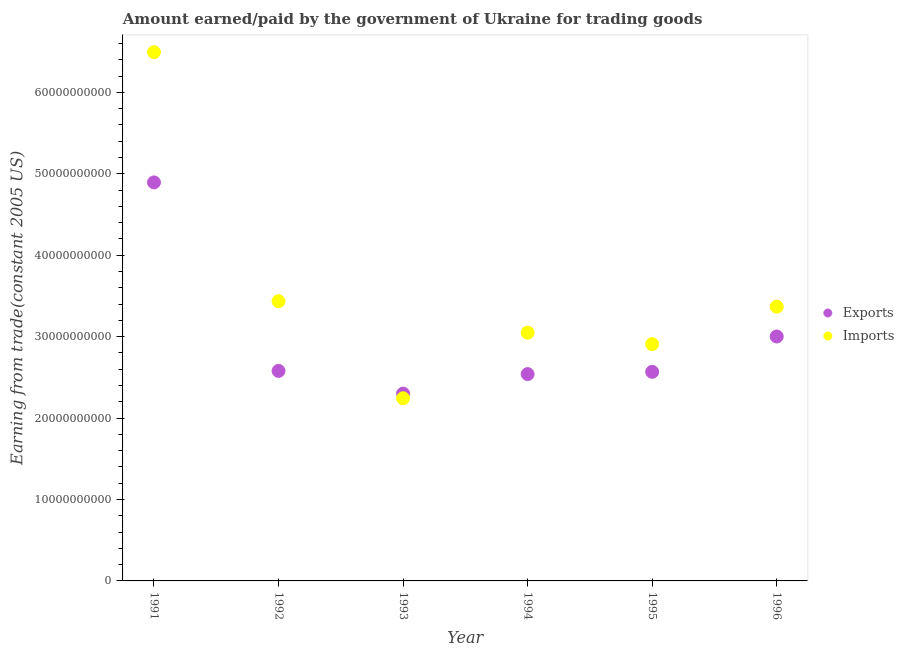Is the number of dotlines equal to the number of legend labels?
Offer a terse response. Yes. What is the amount earned from exports in 1993?
Keep it short and to the point. 2.30e+1. Across all years, what is the maximum amount earned from exports?
Give a very brief answer. 4.89e+1. Across all years, what is the minimum amount paid for imports?
Make the answer very short. 2.24e+1. In which year was the amount earned from exports minimum?
Your answer should be very brief. 1993. What is the total amount earned from exports in the graph?
Offer a very short reply. 1.79e+11. What is the difference between the amount paid for imports in 1991 and that in 1994?
Your answer should be compact. 3.44e+1. What is the difference between the amount paid for imports in 1991 and the amount earned from exports in 1995?
Offer a very short reply. 3.93e+1. What is the average amount paid for imports per year?
Your answer should be compact. 3.58e+1. In the year 1991, what is the difference between the amount earned from exports and amount paid for imports?
Offer a very short reply. -1.60e+1. What is the ratio of the amount paid for imports in 1993 to that in 1995?
Your answer should be very brief. 0.77. Is the amount paid for imports in 1993 less than that in 1996?
Your answer should be very brief. Yes. What is the difference between the highest and the second highest amount earned from exports?
Your response must be concise. 1.89e+1. What is the difference between the highest and the lowest amount paid for imports?
Keep it short and to the point. 4.25e+1. Does the amount paid for imports monotonically increase over the years?
Make the answer very short. No. Is the amount earned from exports strictly less than the amount paid for imports over the years?
Keep it short and to the point. No. How many dotlines are there?
Offer a very short reply. 2. How many years are there in the graph?
Offer a terse response. 6. How many legend labels are there?
Offer a terse response. 2. What is the title of the graph?
Your response must be concise. Amount earned/paid by the government of Ukraine for trading goods. What is the label or title of the Y-axis?
Offer a very short reply. Earning from trade(constant 2005 US). What is the Earning from trade(constant 2005 US) in Exports in 1991?
Keep it short and to the point. 4.89e+1. What is the Earning from trade(constant 2005 US) in Imports in 1991?
Your response must be concise. 6.49e+1. What is the Earning from trade(constant 2005 US) in Exports in 1992?
Your answer should be very brief. 2.58e+1. What is the Earning from trade(constant 2005 US) in Imports in 1992?
Offer a very short reply. 3.43e+1. What is the Earning from trade(constant 2005 US) of Exports in 1993?
Provide a short and direct response. 2.30e+1. What is the Earning from trade(constant 2005 US) of Imports in 1993?
Your answer should be compact. 2.24e+1. What is the Earning from trade(constant 2005 US) in Exports in 1994?
Make the answer very short. 2.54e+1. What is the Earning from trade(constant 2005 US) of Imports in 1994?
Keep it short and to the point. 3.05e+1. What is the Earning from trade(constant 2005 US) in Exports in 1995?
Keep it short and to the point. 2.57e+1. What is the Earning from trade(constant 2005 US) in Imports in 1995?
Offer a very short reply. 2.91e+1. What is the Earning from trade(constant 2005 US) in Exports in 1996?
Your response must be concise. 3.00e+1. What is the Earning from trade(constant 2005 US) in Imports in 1996?
Keep it short and to the point. 3.37e+1. Across all years, what is the maximum Earning from trade(constant 2005 US) in Exports?
Offer a terse response. 4.89e+1. Across all years, what is the maximum Earning from trade(constant 2005 US) in Imports?
Your answer should be compact. 6.49e+1. Across all years, what is the minimum Earning from trade(constant 2005 US) in Exports?
Provide a short and direct response. 2.30e+1. Across all years, what is the minimum Earning from trade(constant 2005 US) of Imports?
Give a very brief answer. 2.24e+1. What is the total Earning from trade(constant 2005 US) of Exports in the graph?
Give a very brief answer. 1.79e+11. What is the total Earning from trade(constant 2005 US) of Imports in the graph?
Provide a succinct answer. 2.15e+11. What is the difference between the Earning from trade(constant 2005 US) in Exports in 1991 and that in 1992?
Ensure brevity in your answer.  2.31e+1. What is the difference between the Earning from trade(constant 2005 US) in Imports in 1991 and that in 1992?
Make the answer very short. 3.06e+1. What is the difference between the Earning from trade(constant 2005 US) of Exports in 1991 and that in 1993?
Make the answer very short. 2.59e+1. What is the difference between the Earning from trade(constant 2005 US) in Imports in 1991 and that in 1993?
Give a very brief answer. 4.25e+1. What is the difference between the Earning from trade(constant 2005 US) in Exports in 1991 and that in 1994?
Make the answer very short. 2.35e+1. What is the difference between the Earning from trade(constant 2005 US) in Imports in 1991 and that in 1994?
Offer a very short reply. 3.44e+1. What is the difference between the Earning from trade(constant 2005 US) in Exports in 1991 and that in 1995?
Offer a terse response. 2.33e+1. What is the difference between the Earning from trade(constant 2005 US) in Imports in 1991 and that in 1995?
Offer a terse response. 3.58e+1. What is the difference between the Earning from trade(constant 2005 US) in Exports in 1991 and that in 1996?
Make the answer very short. 1.89e+1. What is the difference between the Earning from trade(constant 2005 US) of Imports in 1991 and that in 1996?
Your answer should be compact. 3.13e+1. What is the difference between the Earning from trade(constant 2005 US) of Exports in 1992 and that in 1993?
Ensure brevity in your answer.  2.79e+09. What is the difference between the Earning from trade(constant 2005 US) in Imports in 1992 and that in 1993?
Your answer should be compact. 1.19e+1. What is the difference between the Earning from trade(constant 2005 US) of Exports in 1992 and that in 1994?
Keep it short and to the point. 3.93e+08. What is the difference between the Earning from trade(constant 2005 US) in Imports in 1992 and that in 1994?
Keep it short and to the point. 3.87e+09. What is the difference between the Earning from trade(constant 2005 US) in Exports in 1992 and that in 1995?
Give a very brief answer. 1.13e+08. What is the difference between the Earning from trade(constant 2005 US) of Imports in 1992 and that in 1995?
Provide a succinct answer. 5.27e+09. What is the difference between the Earning from trade(constant 2005 US) in Exports in 1992 and that in 1996?
Ensure brevity in your answer.  -4.23e+09. What is the difference between the Earning from trade(constant 2005 US) in Imports in 1992 and that in 1996?
Provide a succinct answer. 6.74e+08. What is the difference between the Earning from trade(constant 2005 US) in Exports in 1993 and that in 1994?
Keep it short and to the point. -2.39e+09. What is the difference between the Earning from trade(constant 2005 US) of Imports in 1993 and that in 1994?
Offer a very short reply. -8.05e+09. What is the difference between the Earning from trade(constant 2005 US) of Exports in 1993 and that in 1995?
Offer a very short reply. -2.67e+09. What is the difference between the Earning from trade(constant 2005 US) in Imports in 1993 and that in 1995?
Offer a very short reply. -6.65e+09. What is the difference between the Earning from trade(constant 2005 US) in Exports in 1993 and that in 1996?
Ensure brevity in your answer.  -7.01e+09. What is the difference between the Earning from trade(constant 2005 US) of Imports in 1993 and that in 1996?
Provide a succinct answer. -1.12e+1. What is the difference between the Earning from trade(constant 2005 US) of Exports in 1994 and that in 1995?
Keep it short and to the point. -2.79e+08. What is the difference between the Earning from trade(constant 2005 US) in Imports in 1994 and that in 1995?
Keep it short and to the point. 1.40e+09. What is the difference between the Earning from trade(constant 2005 US) of Exports in 1994 and that in 1996?
Make the answer very short. -4.62e+09. What is the difference between the Earning from trade(constant 2005 US) in Imports in 1994 and that in 1996?
Provide a short and direct response. -3.19e+09. What is the difference between the Earning from trade(constant 2005 US) in Exports in 1995 and that in 1996?
Provide a short and direct response. -4.34e+09. What is the difference between the Earning from trade(constant 2005 US) in Imports in 1995 and that in 1996?
Your answer should be compact. -4.59e+09. What is the difference between the Earning from trade(constant 2005 US) of Exports in 1991 and the Earning from trade(constant 2005 US) of Imports in 1992?
Offer a very short reply. 1.46e+1. What is the difference between the Earning from trade(constant 2005 US) of Exports in 1991 and the Earning from trade(constant 2005 US) of Imports in 1993?
Your answer should be very brief. 2.65e+1. What is the difference between the Earning from trade(constant 2005 US) in Exports in 1991 and the Earning from trade(constant 2005 US) in Imports in 1994?
Offer a very short reply. 1.85e+1. What is the difference between the Earning from trade(constant 2005 US) of Exports in 1991 and the Earning from trade(constant 2005 US) of Imports in 1995?
Provide a short and direct response. 1.99e+1. What is the difference between the Earning from trade(constant 2005 US) in Exports in 1991 and the Earning from trade(constant 2005 US) in Imports in 1996?
Your answer should be very brief. 1.53e+1. What is the difference between the Earning from trade(constant 2005 US) in Exports in 1992 and the Earning from trade(constant 2005 US) in Imports in 1993?
Ensure brevity in your answer.  3.36e+09. What is the difference between the Earning from trade(constant 2005 US) of Exports in 1992 and the Earning from trade(constant 2005 US) of Imports in 1994?
Offer a terse response. -4.69e+09. What is the difference between the Earning from trade(constant 2005 US) in Exports in 1992 and the Earning from trade(constant 2005 US) in Imports in 1995?
Provide a succinct answer. -3.29e+09. What is the difference between the Earning from trade(constant 2005 US) in Exports in 1992 and the Earning from trade(constant 2005 US) in Imports in 1996?
Your response must be concise. -7.88e+09. What is the difference between the Earning from trade(constant 2005 US) in Exports in 1993 and the Earning from trade(constant 2005 US) in Imports in 1994?
Your answer should be very brief. -7.48e+09. What is the difference between the Earning from trade(constant 2005 US) in Exports in 1993 and the Earning from trade(constant 2005 US) in Imports in 1995?
Offer a terse response. -6.07e+09. What is the difference between the Earning from trade(constant 2005 US) in Exports in 1993 and the Earning from trade(constant 2005 US) in Imports in 1996?
Your answer should be compact. -1.07e+1. What is the difference between the Earning from trade(constant 2005 US) in Exports in 1994 and the Earning from trade(constant 2005 US) in Imports in 1995?
Ensure brevity in your answer.  -3.68e+09. What is the difference between the Earning from trade(constant 2005 US) of Exports in 1994 and the Earning from trade(constant 2005 US) of Imports in 1996?
Provide a succinct answer. -8.28e+09. What is the difference between the Earning from trade(constant 2005 US) in Exports in 1995 and the Earning from trade(constant 2005 US) in Imports in 1996?
Ensure brevity in your answer.  -8.00e+09. What is the average Earning from trade(constant 2005 US) in Exports per year?
Offer a terse response. 2.98e+1. What is the average Earning from trade(constant 2005 US) in Imports per year?
Your response must be concise. 3.58e+1. In the year 1991, what is the difference between the Earning from trade(constant 2005 US) of Exports and Earning from trade(constant 2005 US) of Imports?
Offer a very short reply. -1.60e+1. In the year 1992, what is the difference between the Earning from trade(constant 2005 US) of Exports and Earning from trade(constant 2005 US) of Imports?
Keep it short and to the point. -8.56e+09. In the year 1993, what is the difference between the Earning from trade(constant 2005 US) in Exports and Earning from trade(constant 2005 US) in Imports?
Make the answer very short. 5.76e+08. In the year 1994, what is the difference between the Earning from trade(constant 2005 US) of Exports and Earning from trade(constant 2005 US) of Imports?
Make the answer very short. -5.08e+09. In the year 1995, what is the difference between the Earning from trade(constant 2005 US) in Exports and Earning from trade(constant 2005 US) in Imports?
Offer a very short reply. -3.40e+09. In the year 1996, what is the difference between the Earning from trade(constant 2005 US) of Exports and Earning from trade(constant 2005 US) of Imports?
Provide a short and direct response. -3.66e+09. What is the ratio of the Earning from trade(constant 2005 US) of Exports in 1991 to that in 1992?
Provide a succinct answer. 1.9. What is the ratio of the Earning from trade(constant 2005 US) of Imports in 1991 to that in 1992?
Offer a terse response. 1.89. What is the ratio of the Earning from trade(constant 2005 US) of Exports in 1991 to that in 1993?
Keep it short and to the point. 2.13. What is the ratio of the Earning from trade(constant 2005 US) of Imports in 1991 to that in 1993?
Your answer should be compact. 2.89. What is the ratio of the Earning from trade(constant 2005 US) in Exports in 1991 to that in 1994?
Provide a short and direct response. 1.93. What is the ratio of the Earning from trade(constant 2005 US) of Imports in 1991 to that in 1994?
Your response must be concise. 2.13. What is the ratio of the Earning from trade(constant 2005 US) of Exports in 1991 to that in 1995?
Make the answer very short. 1.91. What is the ratio of the Earning from trade(constant 2005 US) in Imports in 1991 to that in 1995?
Make the answer very short. 2.23. What is the ratio of the Earning from trade(constant 2005 US) of Exports in 1991 to that in 1996?
Provide a succinct answer. 1.63. What is the ratio of the Earning from trade(constant 2005 US) of Imports in 1991 to that in 1996?
Offer a terse response. 1.93. What is the ratio of the Earning from trade(constant 2005 US) in Exports in 1992 to that in 1993?
Provide a short and direct response. 1.12. What is the ratio of the Earning from trade(constant 2005 US) of Imports in 1992 to that in 1993?
Give a very brief answer. 1.53. What is the ratio of the Earning from trade(constant 2005 US) of Exports in 1992 to that in 1994?
Provide a short and direct response. 1.02. What is the ratio of the Earning from trade(constant 2005 US) in Imports in 1992 to that in 1994?
Offer a very short reply. 1.13. What is the ratio of the Earning from trade(constant 2005 US) of Exports in 1992 to that in 1995?
Offer a terse response. 1. What is the ratio of the Earning from trade(constant 2005 US) of Imports in 1992 to that in 1995?
Ensure brevity in your answer.  1.18. What is the ratio of the Earning from trade(constant 2005 US) in Exports in 1992 to that in 1996?
Ensure brevity in your answer.  0.86. What is the ratio of the Earning from trade(constant 2005 US) of Exports in 1993 to that in 1994?
Offer a very short reply. 0.91. What is the ratio of the Earning from trade(constant 2005 US) in Imports in 1993 to that in 1994?
Your response must be concise. 0.74. What is the ratio of the Earning from trade(constant 2005 US) in Exports in 1993 to that in 1995?
Provide a succinct answer. 0.9. What is the ratio of the Earning from trade(constant 2005 US) in Imports in 1993 to that in 1995?
Provide a succinct answer. 0.77. What is the ratio of the Earning from trade(constant 2005 US) of Exports in 1993 to that in 1996?
Give a very brief answer. 0.77. What is the ratio of the Earning from trade(constant 2005 US) in Imports in 1993 to that in 1996?
Your answer should be compact. 0.67. What is the ratio of the Earning from trade(constant 2005 US) in Exports in 1994 to that in 1995?
Provide a short and direct response. 0.99. What is the ratio of the Earning from trade(constant 2005 US) in Imports in 1994 to that in 1995?
Provide a succinct answer. 1.05. What is the ratio of the Earning from trade(constant 2005 US) of Exports in 1994 to that in 1996?
Your response must be concise. 0.85. What is the ratio of the Earning from trade(constant 2005 US) of Imports in 1994 to that in 1996?
Provide a short and direct response. 0.91. What is the ratio of the Earning from trade(constant 2005 US) of Exports in 1995 to that in 1996?
Offer a very short reply. 0.86. What is the ratio of the Earning from trade(constant 2005 US) in Imports in 1995 to that in 1996?
Offer a terse response. 0.86. What is the difference between the highest and the second highest Earning from trade(constant 2005 US) in Exports?
Offer a very short reply. 1.89e+1. What is the difference between the highest and the second highest Earning from trade(constant 2005 US) in Imports?
Provide a short and direct response. 3.06e+1. What is the difference between the highest and the lowest Earning from trade(constant 2005 US) of Exports?
Your answer should be compact. 2.59e+1. What is the difference between the highest and the lowest Earning from trade(constant 2005 US) of Imports?
Provide a succinct answer. 4.25e+1. 